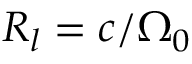<formula> <loc_0><loc_0><loc_500><loc_500>R _ { l } = c / \Omega _ { 0 }</formula> 